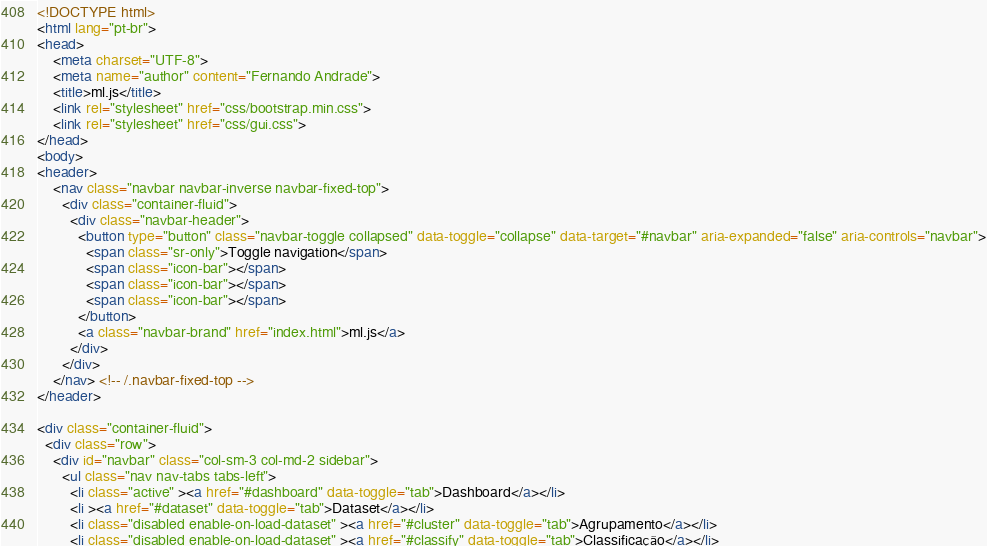Convert code to text. <code><loc_0><loc_0><loc_500><loc_500><_HTML_><!DOCTYPE html>
<html lang="pt-br">
<head>
    <meta charset="UTF-8">
    <meta name="author" content="Fernando Andrade">
    <title>ml.js</title>
    <link rel="stylesheet" href="css/bootstrap.min.css">
    <link rel="stylesheet" href="css/gui.css">
</head>
<body>
<header>
    <nav class="navbar navbar-inverse navbar-fixed-top">
      <div class="container-fluid">
        <div class="navbar-header">
          <button type="button" class="navbar-toggle collapsed" data-toggle="collapse" data-target="#navbar" aria-expanded="false" aria-controls="navbar">
            <span class="sr-only">Toggle navigation</span>
            <span class="icon-bar"></span>
            <span class="icon-bar"></span>
            <span class="icon-bar"></span>
          </button>
          <a class="navbar-brand" href="index.html">ml.js</a>
        </div>
      </div>
    </nav> <!-- /.navbar-fixed-top -->
</header>

<div class="container-fluid">
  <div class="row">
    <div id="navbar" class="col-sm-3 col-md-2 sidebar">
      <ul class="nav nav-tabs tabs-left">
        <li class="active" ><a href="#dashboard" data-toggle="tab">Dashboard</a></li>
        <li ><a href="#dataset" data-toggle="tab">Dataset</a></li>
        <li class="disabled enable-on-load-dataset" ><a href="#cluster" data-toggle="tab">Agrupamento</a></li>
        <li class="disabled enable-on-load-dataset" ><a href="#classify" data-toggle="tab">Classificação</a></li></code> 